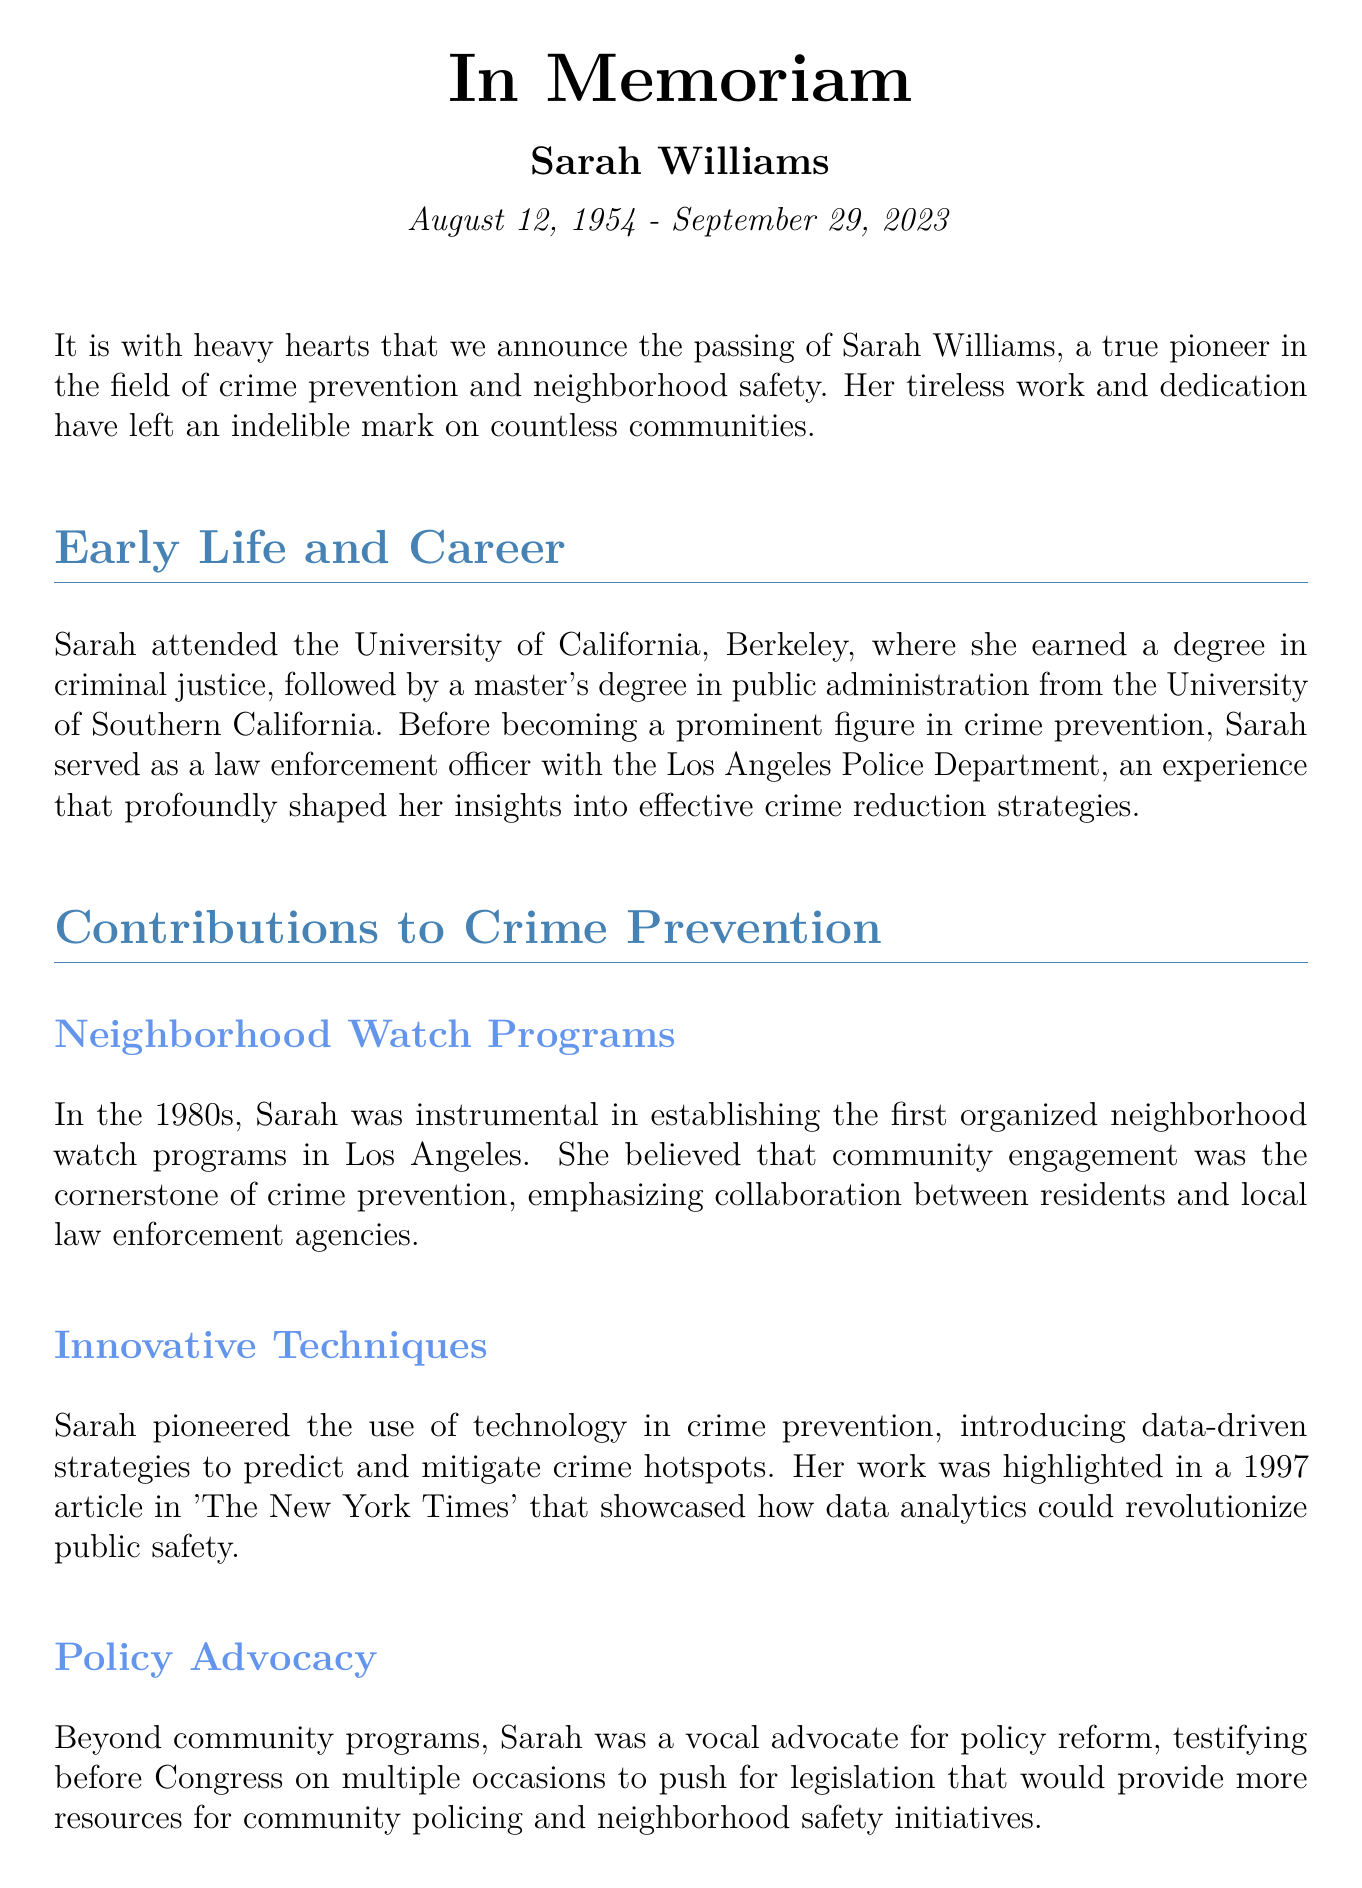What year was Sarah Williams born? The document states that Sarah Williams was born on August 12, 1954.
Answer: 1954 What award did Sarah receive in 2005? The document mentions that Sarah received the Attorney General's Award for Distinguished Service in Policing in 2005.
Answer: Attorney General's Award Which two degrees did Sarah earn? Sarah earned a degree in criminal justice and a master's degree in public administration, as detailed in her early life section.
Answer: Criminal justice, Public administration What title did Sarah author in the field of crime prevention? The document lists one of the books authored by Sarah as 'Safe Streets: The Power of Community Policing.'
Answer: Safe Streets: The Power of Community Policing What did Sarah emphasize as the cornerstone of crime prevention? The document notes that Sarah emphasized community engagement as the cornerstone of crime prevention.
Answer: Community engagement What significant day was declared in honor of Sarah in 2018? The document states that June 15th was declared 'Sarah Williams Day' in 2018 to celebrate her contributions.
Answer: Sarah Williams Day In what capacity did Sarah serve at the Los Angeles Police Department? Sarah served as a law enforcement officer with the Los Angeles Police Department, as per her career information.
Answer: Law enforcement officer What was a key focus of Sarah's policy advocacy? The document indicates that Sarah advocated for legislation providing resources for community policing and neighborhood safety initiatives.
Answer: Resources for community policing Who are the immediate family members mentioned as survivors of Sarah? The document lists her husband Kenneth Williams and their two children, Emily and Michael, as survivors.
Answer: Kenneth Williams, Emily, Michael 